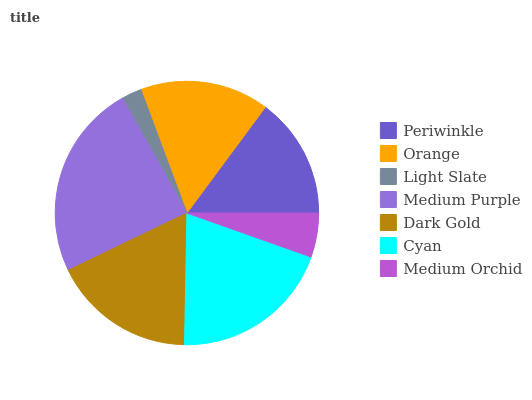Is Light Slate the minimum?
Answer yes or no. Yes. Is Medium Purple the maximum?
Answer yes or no. Yes. Is Orange the minimum?
Answer yes or no. No. Is Orange the maximum?
Answer yes or no. No. Is Orange greater than Periwinkle?
Answer yes or no. Yes. Is Periwinkle less than Orange?
Answer yes or no. Yes. Is Periwinkle greater than Orange?
Answer yes or no. No. Is Orange less than Periwinkle?
Answer yes or no. No. Is Orange the high median?
Answer yes or no. Yes. Is Orange the low median?
Answer yes or no. Yes. Is Periwinkle the high median?
Answer yes or no. No. Is Periwinkle the low median?
Answer yes or no. No. 